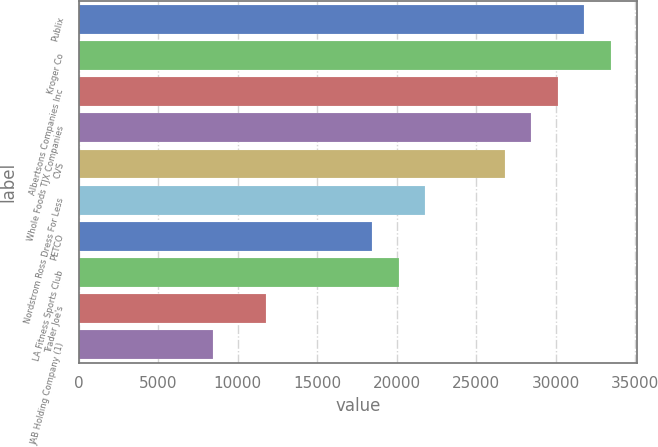<chart> <loc_0><loc_0><loc_500><loc_500><bar_chart><fcel>Publix<fcel>Kroger Co<fcel>Albertsons Companies Inc<fcel>Whole Foods TJX Companies<fcel>CVS<fcel>Nordstrom Ross Dress For Less<fcel>PETCO<fcel>LA Fitness Sports Club<fcel>Trader Joe's<fcel>JAB Holding Company (1)<nl><fcel>31792.4<fcel>33460<fcel>30124.8<fcel>28457.2<fcel>26789.6<fcel>21786.8<fcel>18451.6<fcel>20119.2<fcel>11781.2<fcel>8446<nl></chart> 